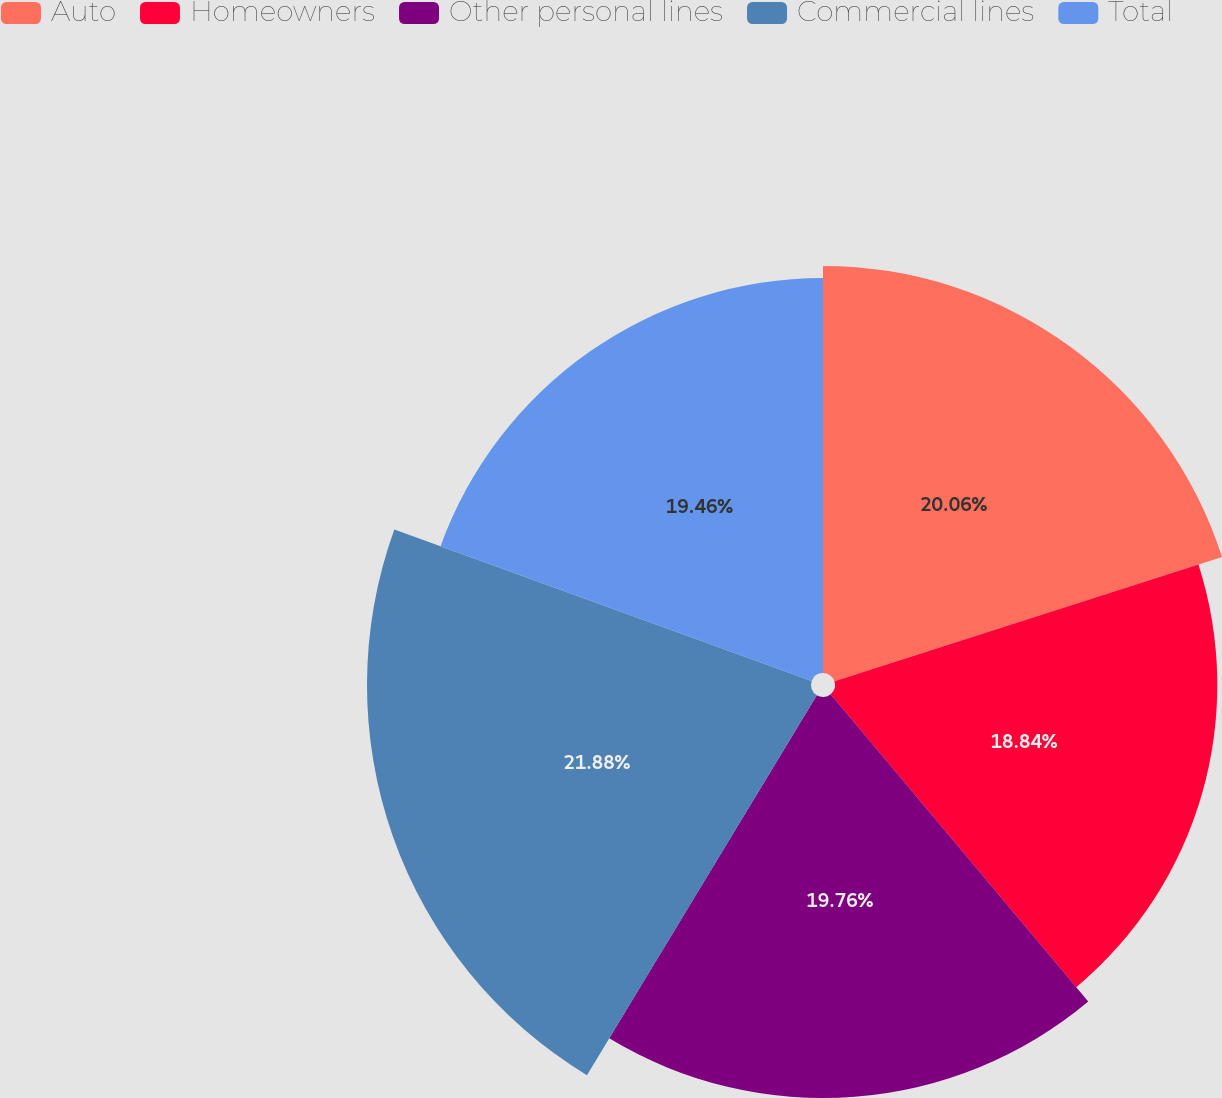Convert chart to OTSL. <chart><loc_0><loc_0><loc_500><loc_500><pie_chart><fcel>Auto<fcel>Homeowners<fcel>Other personal lines<fcel>Commercial lines<fcel>Total<nl><fcel>20.06%<fcel>18.84%<fcel>19.76%<fcel>21.88%<fcel>19.46%<nl></chart> 